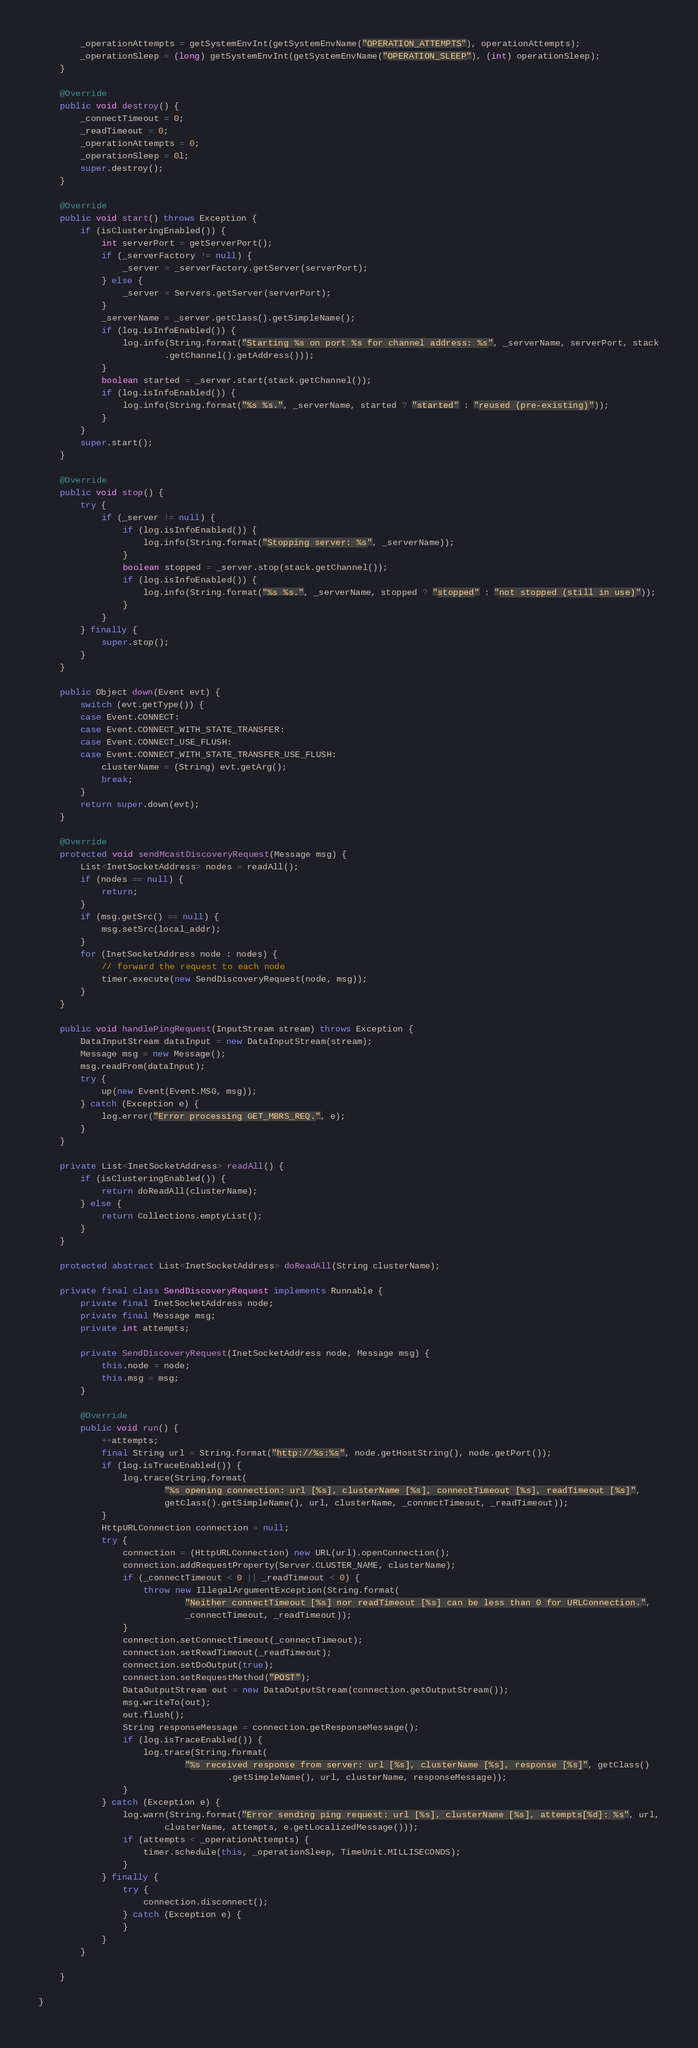<code> <loc_0><loc_0><loc_500><loc_500><_Java_>        _operationAttempts = getSystemEnvInt(getSystemEnvName("OPERATION_ATTEMPTS"), operationAttempts);
        _operationSleep = (long) getSystemEnvInt(getSystemEnvName("OPERATION_SLEEP"), (int) operationSleep);
    }

    @Override
    public void destroy() {
        _connectTimeout = 0;
        _readTimeout = 0;
        _operationAttempts = 0;
        _operationSleep = 0l;
        super.destroy();
    }

    @Override
    public void start() throws Exception {
        if (isClusteringEnabled()) {
            int serverPort = getServerPort();
            if (_serverFactory != null) {
                _server = _serverFactory.getServer(serverPort);
            } else {
                _server = Servers.getServer(serverPort);
            }
            _serverName = _server.getClass().getSimpleName();
            if (log.isInfoEnabled()) {
                log.info(String.format("Starting %s on port %s for channel address: %s", _serverName, serverPort, stack
                        .getChannel().getAddress()));
            }
            boolean started = _server.start(stack.getChannel());
            if (log.isInfoEnabled()) {
                log.info(String.format("%s %s.", _serverName, started ? "started" : "reused (pre-existing)"));
            }
        }
        super.start();
    }

    @Override
    public void stop() {
        try {
            if (_server != null) {
                if (log.isInfoEnabled()) {
                    log.info(String.format("Stopping server: %s", _serverName));
                }
                boolean stopped = _server.stop(stack.getChannel());
                if (log.isInfoEnabled()) {
                    log.info(String.format("%s %s.", _serverName, stopped ? "stopped" : "not stopped (still in use)"));
                }
            }
        } finally {
            super.stop();
        }
    }

    public Object down(Event evt) {
        switch (evt.getType()) {
        case Event.CONNECT:
        case Event.CONNECT_WITH_STATE_TRANSFER:
        case Event.CONNECT_USE_FLUSH:
        case Event.CONNECT_WITH_STATE_TRANSFER_USE_FLUSH:
            clusterName = (String) evt.getArg();
            break;
        }
        return super.down(evt);
    }

    @Override
    protected void sendMcastDiscoveryRequest(Message msg) {
        List<InetSocketAddress> nodes = readAll();
        if (nodes == null) {
            return;
        }
        if (msg.getSrc() == null) {
            msg.setSrc(local_addr);
        }
        for (InetSocketAddress node : nodes) {
            // forward the request to each node
            timer.execute(new SendDiscoveryRequest(node, msg));
        }
    }

    public void handlePingRequest(InputStream stream) throws Exception {
        DataInputStream dataInput = new DataInputStream(stream);
        Message msg = new Message();
        msg.readFrom(dataInput);
        try {
            up(new Event(Event.MSG, msg));
        } catch (Exception e) {
            log.error("Error processing GET_MBRS_REQ.", e);
        }
    }

    private List<InetSocketAddress> readAll() {
        if (isClusteringEnabled()) {
            return doReadAll(clusterName);
        } else {
            return Collections.emptyList();
        }
    }

    protected abstract List<InetSocketAddress> doReadAll(String clusterName);

    private final class SendDiscoveryRequest implements Runnable {
        private final InetSocketAddress node;
        private final Message msg;
        private int attempts;

        private SendDiscoveryRequest(InetSocketAddress node, Message msg) {
            this.node = node;
            this.msg = msg;
        }

        @Override
        public void run() {
            ++attempts;
            final String url = String.format("http://%s:%s", node.getHostString(), node.getPort());
            if (log.isTraceEnabled()) {
                log.trace(String.format(
                        "%s opening connection: url [%s], clusterName [%s], connectTimeout [%s], readTimeout [%s]",
                        getClass().getSimpleName(), url, clusterName, _connectTimeout, _readTimeout));
            }
            HttpURLConnection connection = null;
            try {
                connection = (HttpURLConnection) new URL(url).openConnection();
                connection.addRequestProperty(Server.CLUSTER_NAME, clusterName);
                if (_connectTimeout < 0 || _readTimeout < 0) {
                    throw new IllegalArgumentException(String.format(
                            "Neither connectTimeout [%s] nor readTimeout [%s] can be less than 0 for URLConnection.",
                            _connectTimeout, _readTimeout));
                }
                connection.setConnectTimeout(_connectTimeout);
                connection.setReadTimeout(_readTimeout);
                connection.setDoOutput(true);
                connection.setRequestMethod("POST");
                DataOutputStream out = new DataOutputStream(connection.getOutputStream());
                msg.writeTo(out);
                out.flush();
                String responseMessage = connection.getResponseMessage();
                if (log.isTraceEnabled()) {
                    log.trace(String.format(
                            "%s received response from server: url [%s], clusterName [%s], response [%s]", getClass()
                                    .getSimpleName(), url, clusterName, responseMessage));
                }
            } catch (Exception e) {
                log.warn(String.format("Error sending ping request: url [%s], clusterName [%s], attempts[%d]: %s", url,
                        clusterName, attempts, e.getLocalizedMessage()));
                if (attempts < _operationAttempts) {
                    timer.schedule(this, _operationSleep, TimeUnit.MILLISECONDS);
                }
            } finally {
                try {
                    connection.disconnect();
                } catch (Exception e) {
                }
            }
        }

    }

}
</code> 